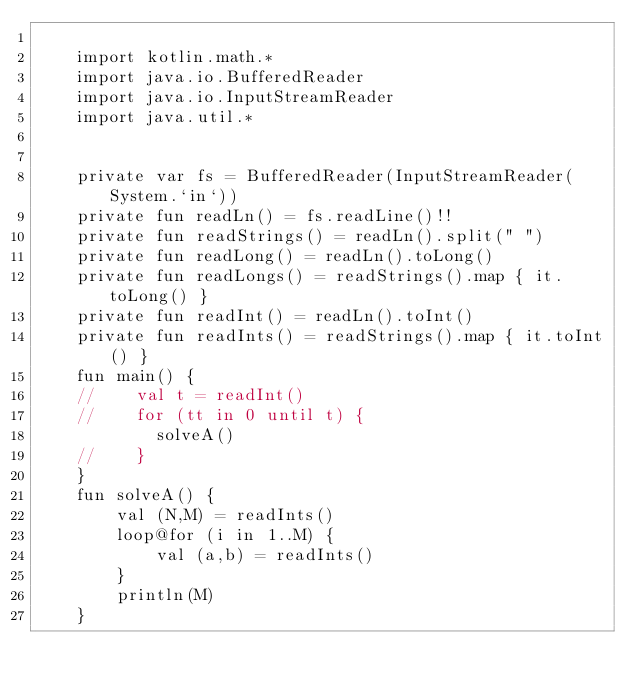Convert code to text. <code><loc_0><loc_0><loc_500><loc_500><_Kotlin_>
    import kotlin.math.*
    import java.io.BufferedReader
    import java.io.InputStreamReader
    import java.util.*


    private var fs = BufferedReader(InputStreamReader(System.`in`))
    private fun readLn() = fs.readLine()!!
    private fun readStrings() = readLn().split(" ")
    private fun readLong() = readLn().toLong()
    private fun readLongs() = readStrings().map { it.toLong() }
    private fun readInt() = readLn().toInt()
    private fun readInts() = readStrings().map { it.toInt() }
    fun main() {
    //    val t = readInt()
    //    for (tt in 0 until t) {
            solveA()
    //    }
    }
    fun solveA() {
        val (N,M) = readInts()
        loop@for (i in 1..M) {
            val (a,b) = readInts()
        }
        println(M)
    }

</code> 